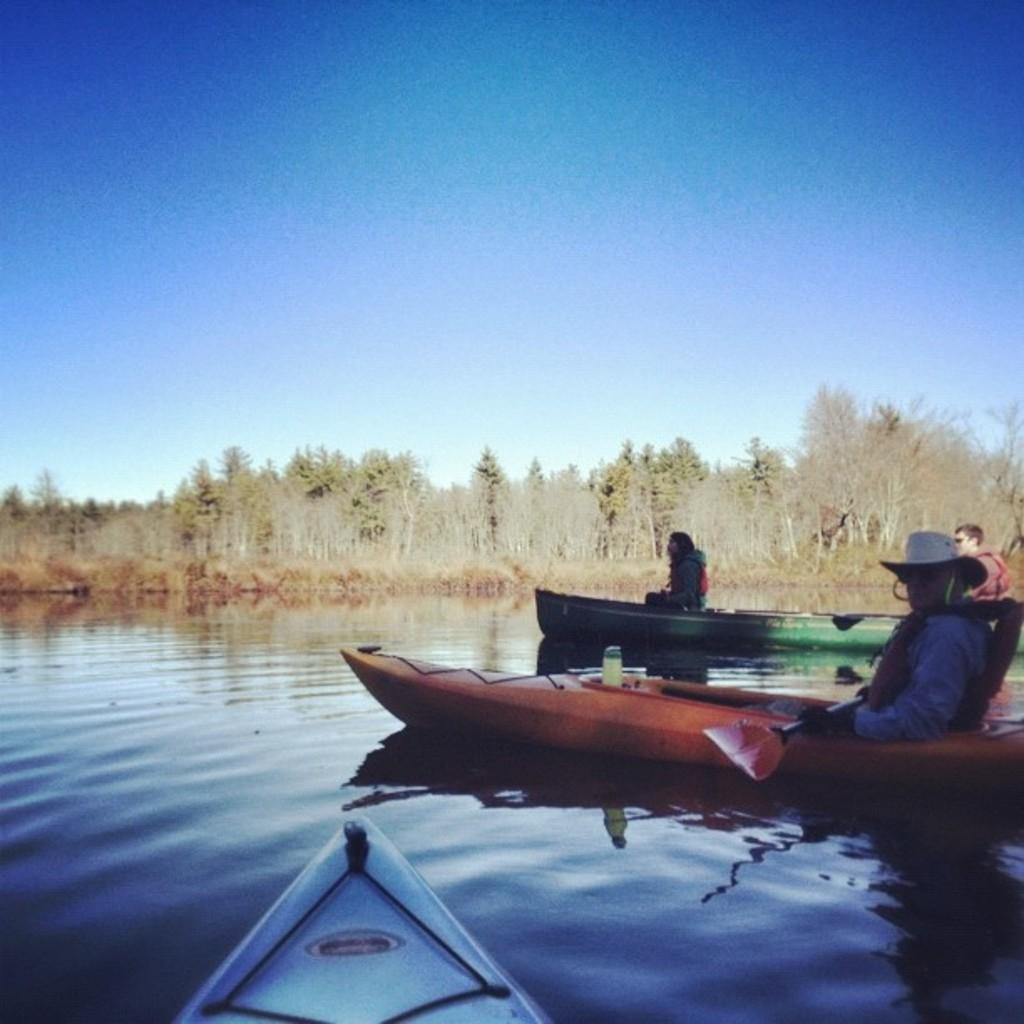What are the people in the image doing? The people in the image are sitting in boats. What can be seen in the background of the image? There are trees visible in the image. What is visible above the trees and boats in the image? The sky is visible in the image. What is the water surface in the image being used for? There are boats on the water surface in the image. What type of grain is being harvested in the image? There is no grain present in the image; it features people sitting in boats on a water surface with trees and sky visible in the background. 